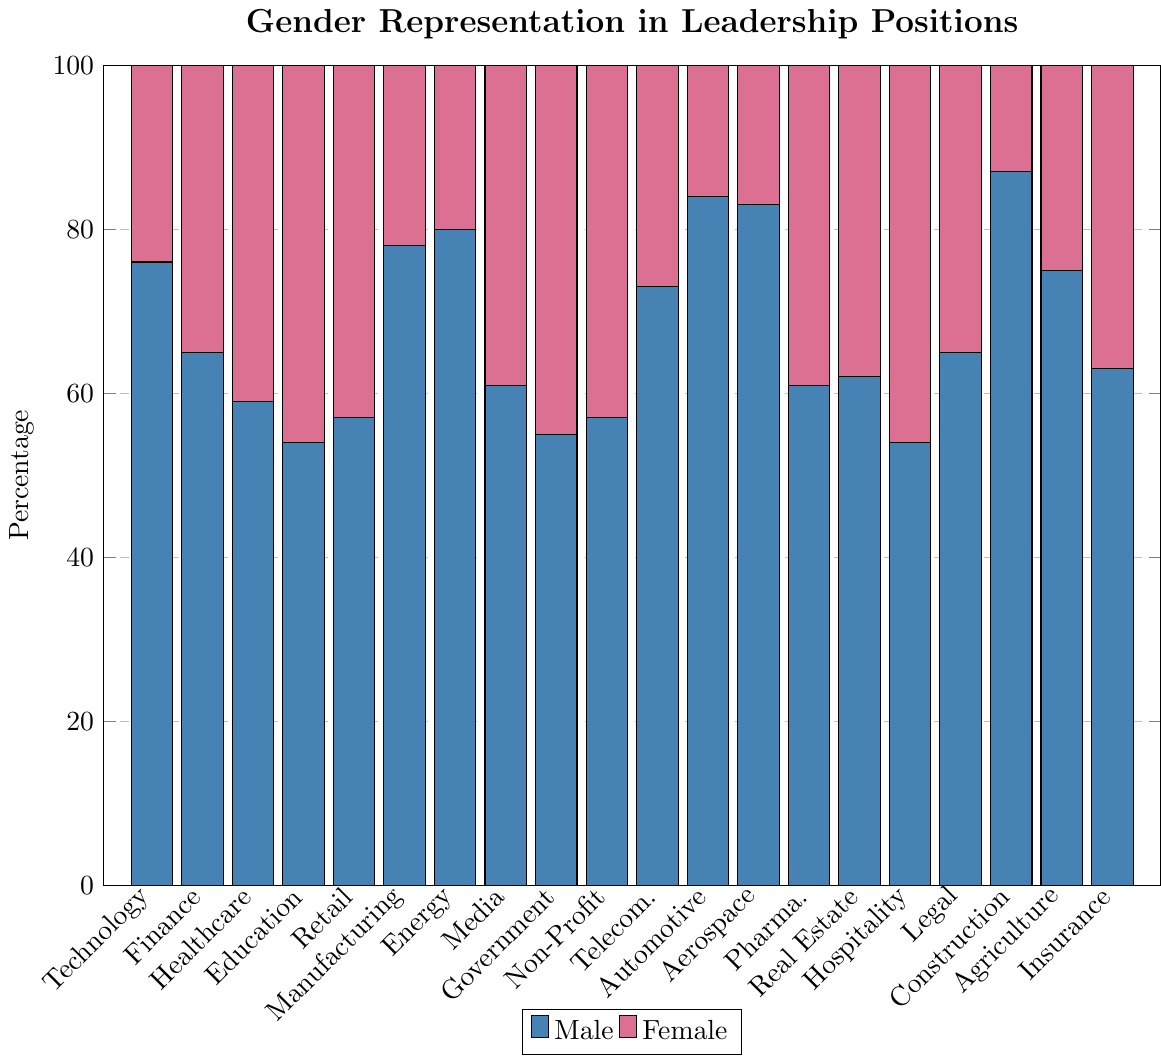Which industry has the highest percentage of male leaders? By visually inspecting the heights of the blue bars, Construction has the tallest blue bar, indicating the highest percentage of male leaders.
Answer: Construction Which two industries have the closest gender representation? By comparing the heights of the blue and pink bars, Education and Hospitality both have relatively balanced gender representation with the smallest differences between male and female percentages.
Answer: Education and Hospitality How does the percentage of female leaders in Technology compare to Healthcare? The pink bar for Healthcare is higher than the pink bar for Technology, indicating that Healthcare has a higher percentage of female leaders than Technology.
Answer: Healthcare What is the difference in the percentage of female leaders between Manufacturing and Retail? The pink bar for Manufacturing is at 22 while Retail is at 43. The difference is \(43 - 22\).
Answer: 21 Which sector has a greater gender disparity, Automotive or Aerospace? Both industries have tall blue bars with relatively shorter pink bars, but by comparing visually, the pink bar in Automotive (16) is shorter compared to Aerospace (17), indicating a slightly greater gender disparity in Automotive.
Answer: Automotive What is the average percentage of female leaders across all industries? Sum the percentages of female leaders across all industries (24+35+41+46+43+22+20+39+45+43+27+16+17+39+38+46+35+13+25+37) and divide by the number of industries (20). The sum is 611, so the average is \( 611 / 20 \approx 30.55 \).
Answer: 30.55 Does the Energy industry have a higher percentage of female leaders compared to Agriculture? The pink bar for Energy is at 20 whereas for Agriculture it is at 25, indicating that Agriculture has a higher percentage of female leaders.
Answer: Agriculture Which industry has the least percentage of female leaders? The smallest pink bar indicates the least percentage of female leaders, which is in Construction (13).
Answer: Construction What is the combined percentage of male leaders in Government and Media? The blue bar for Government is at 55 and for Media is at 61. Adding these two gives \( 55 + 61 = 116 \).
Answer: 116 Which industry has a nearly equal percentage of male and female leaders? By visually inspecting the bar lengths, Education and Hospitality appear most balanced with very close heights of blue and pink bars.
Answer: Education and Hospitality 